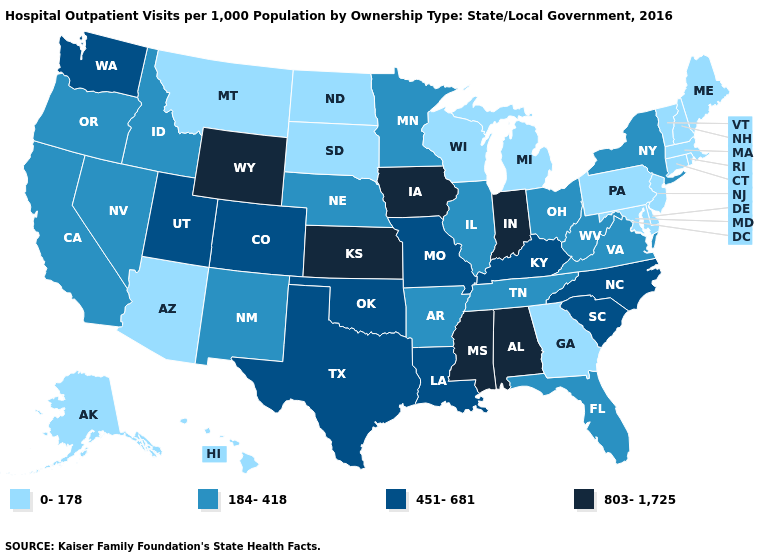What is the lowest value in the USA?
Quick response, please. 0-178. Name the states that have a value in the range 451-681?
Write a very short answer. Colorado, Kentucky, Louisiana, Missouri, North Carolina, Oklahoma, South Carolina, Texas, Utah, Washington. What is the value of Missouri?
Keep it brief. 451-681. What is the value of Pennsylvania?
Answer briefly. 0-178. Name the states that have a value in the range 184-418?
Give a very brief answer. Arkansas, California, Florida, Idaho, Illinois, Minnesota, Nebraska, Nevada, New Mexico, New York, Ohio, Oregon, Tennessee, Virginia, West Virginia. What is the highest value in states that border Florida?
Answer briefly. 803-1,725. Name the states that have a value in the range 451-681?
Answer briefly. Colorado, Kentucky, Louisiana, Missouri, North Carolina, Oklahoma, South Carolina, Texas, Utah, Washington. Does Wyoming have the highest value in the West?
Give a very brief answer. Yes. What is the value of Washington?
Concise answer only. 451-681. What is the value of New Mexico?
Write a very short answer. 184-418. What is the value of Wisconsin?
Short answer required. 0-178. Name the states that have a value in the range 451-681?
Write a very short answer. Colorado, Kentucky, Louisiana, Missouri, North Carolina, Oklahoma, South Carolina, Texas, Utah, Washington. What is the value of Florida?
Be succinct. 184-418. How many symbols are there in the legend?
Concise answer only. 4. Does Wyoming have the highest value in the West?
Answer briefly. Yes. 